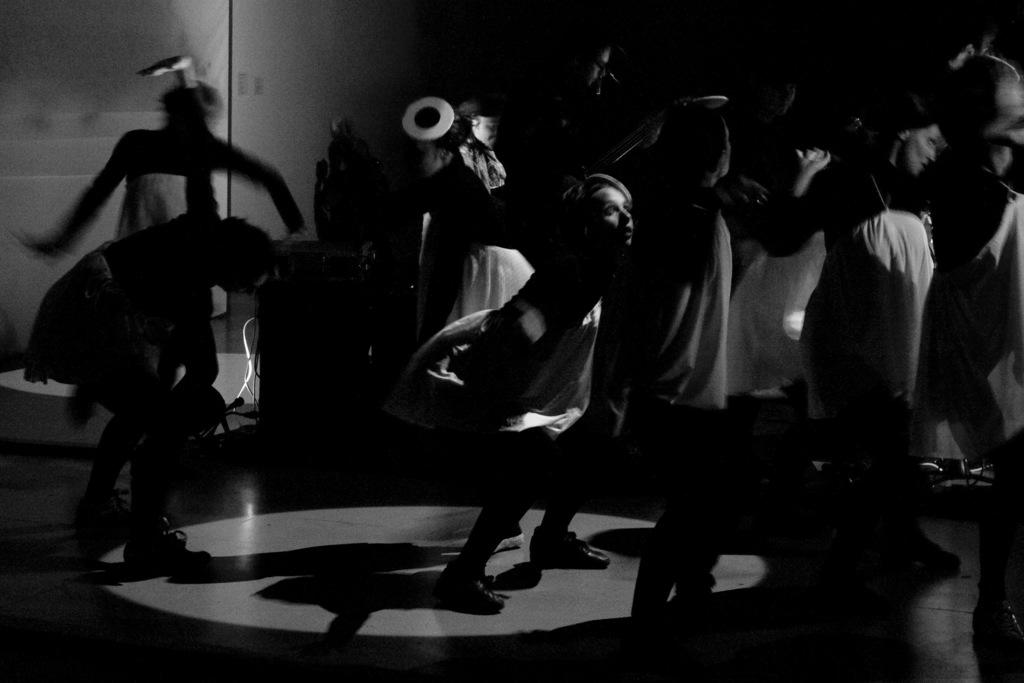What is the color scheme of the image? The image is black and white. What can be seen in the image? There is a group of people in the image. Where are the people located in the image? The people are standing on the floor. What is visible in the background of the image? There is a wall in the background of the image. What type of flesh can be seen on the hands of the people in the image? There is no flesh visible in the image, as it is black and white. Additionally, the image does not show the hands of the people. 